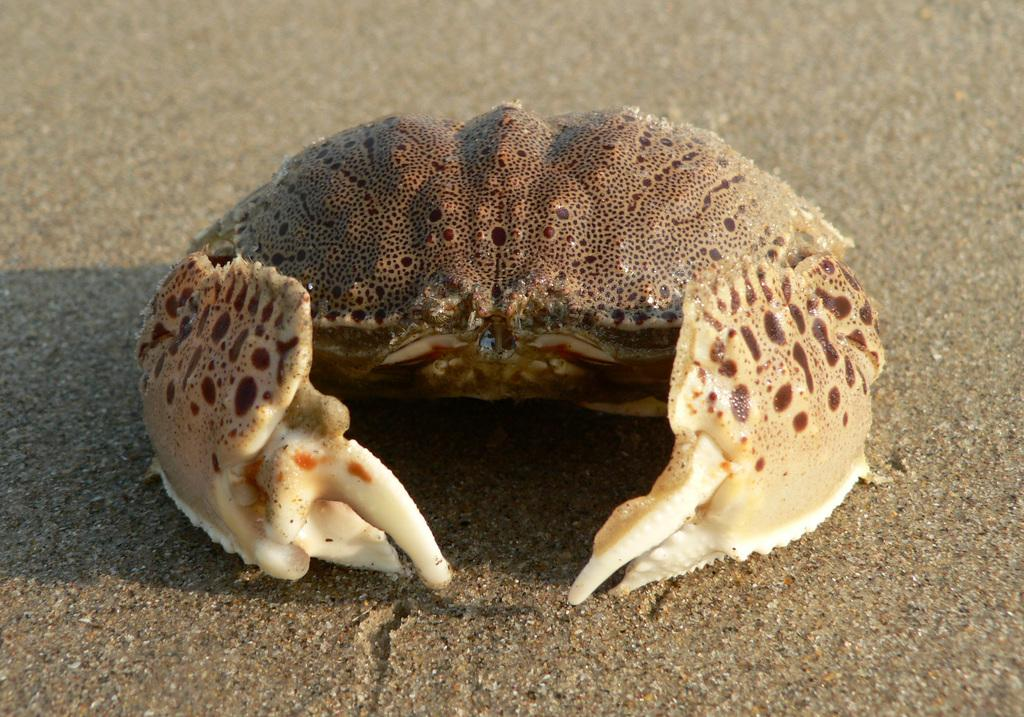What animal is present in the image? There is a crab in the image. Where is the crab located? The crab is in the sand. What is the weight of the zebra in the image? There is no zebra present in the image, so it is not possible to determine its weight. 